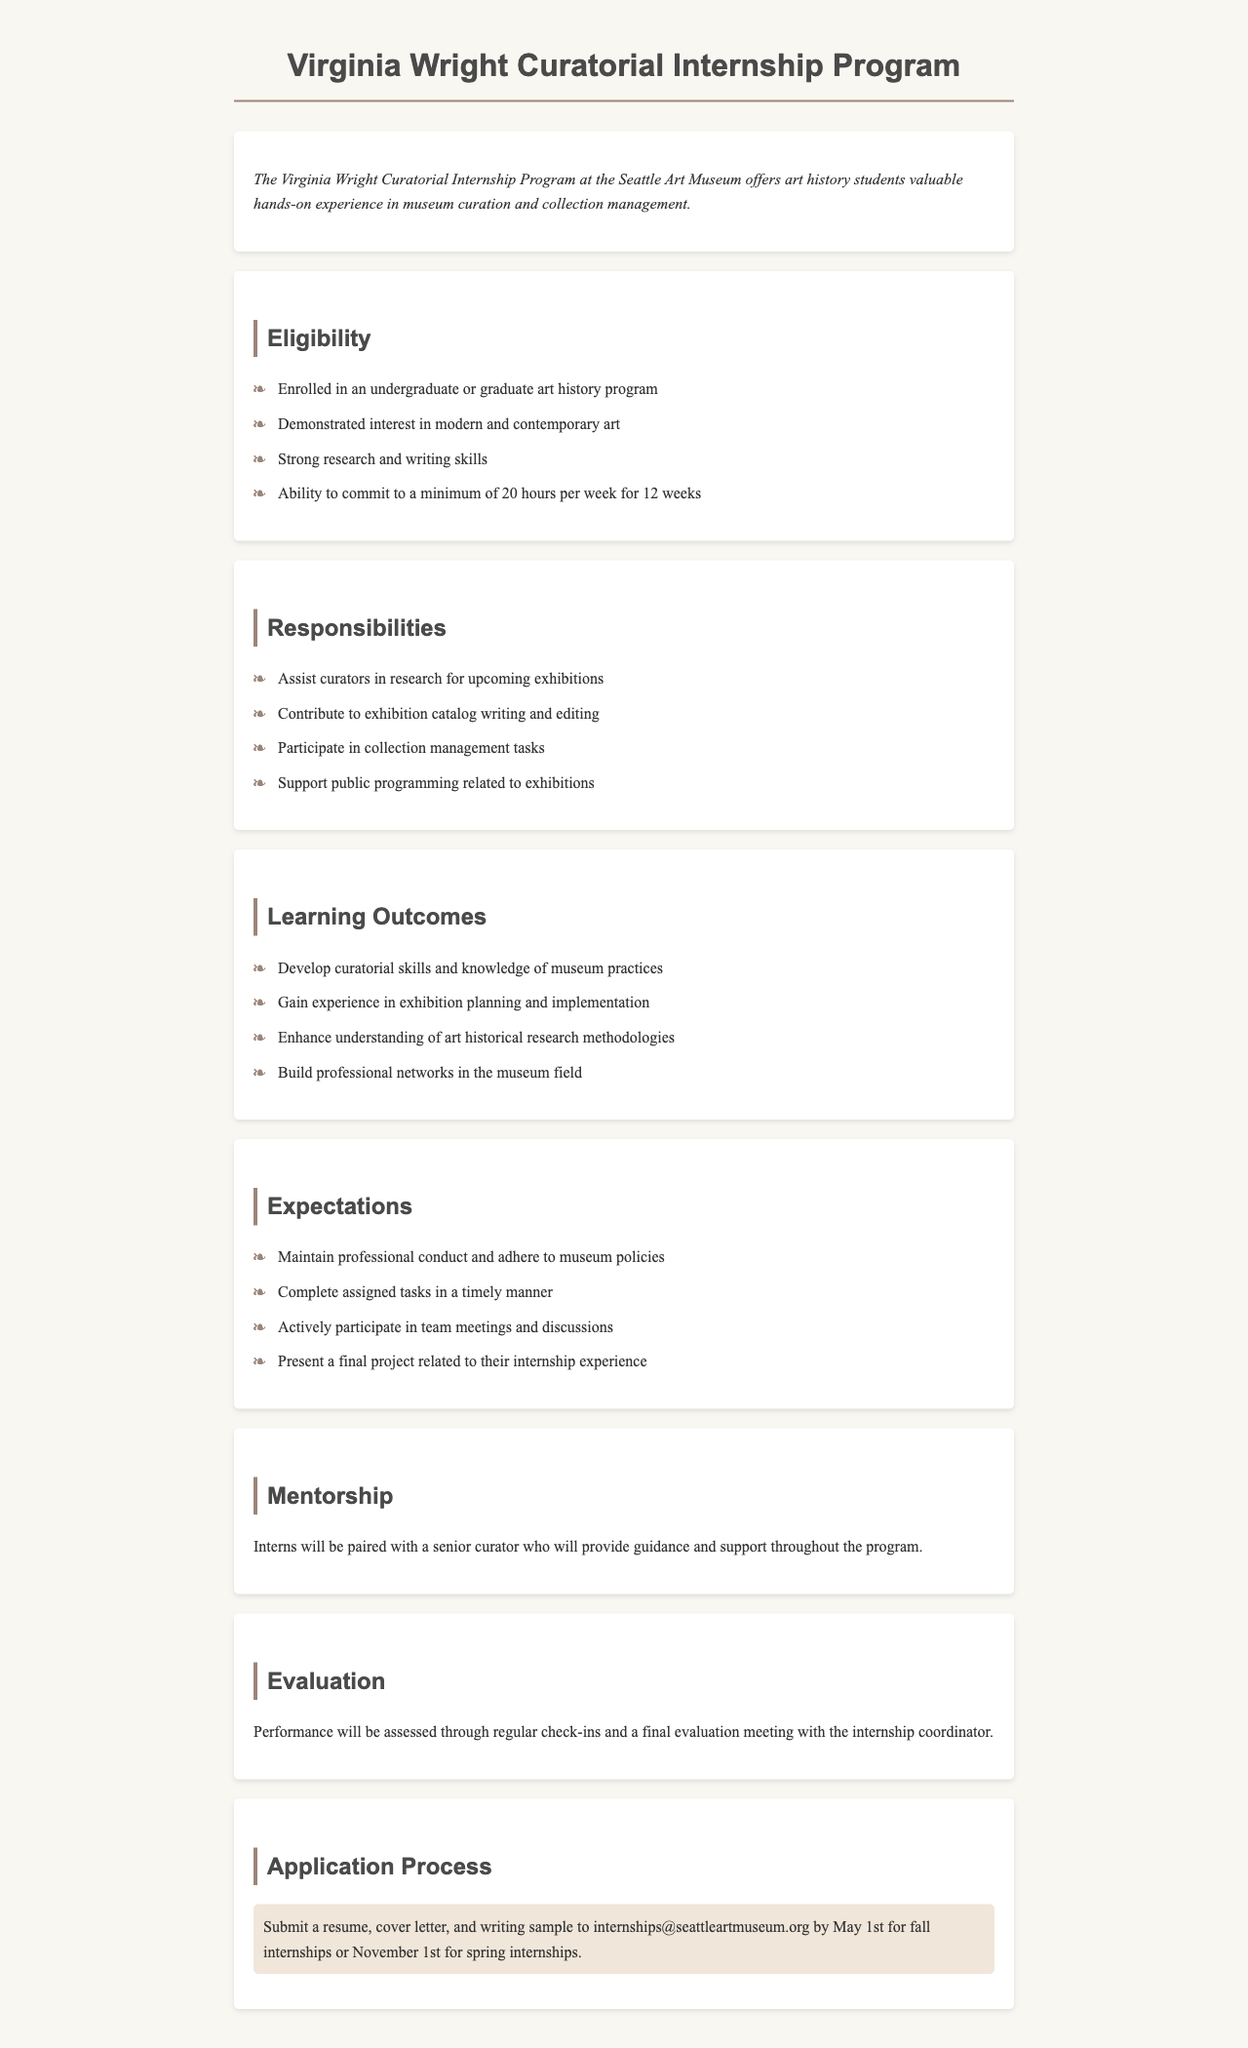What is the minimum weekly hour commitment? The document states that interns must commit to a minimum of 20 hours per week for 12 weeks.
Answer: 20 hours Who will provide guidance to interns? The document mentions that interns will be paired with a senior curator who provides guidance and support.
Answer: Senior curator What is one responsibility of the interns? The document lists responsibilities including assisting curators in research for upcoming exhibitions.
Answer: Research for upcoming exhibitions What is the application deadline for fall internships? According to the document, the application must be submitted by May 1st for fall internships.
Answer: May 1st How many learning outcomes are listed? The document outlines four learning outcomes for the interns.
Answer: Four What type of document is this? This document is a policy outlining an internship program specifically for art history students.
Answer: Internship policy document What must be submitted with the application? The document requires a resume, cover letter, and writing sample to be submitted with the application.
Answer: Resume, cover letter, writing sample What will happen during the final evaluation? The document indicates that performance will be assessed through a final evaluation meeting with the internship coordinator.
Answer: Final evaluation meeting 